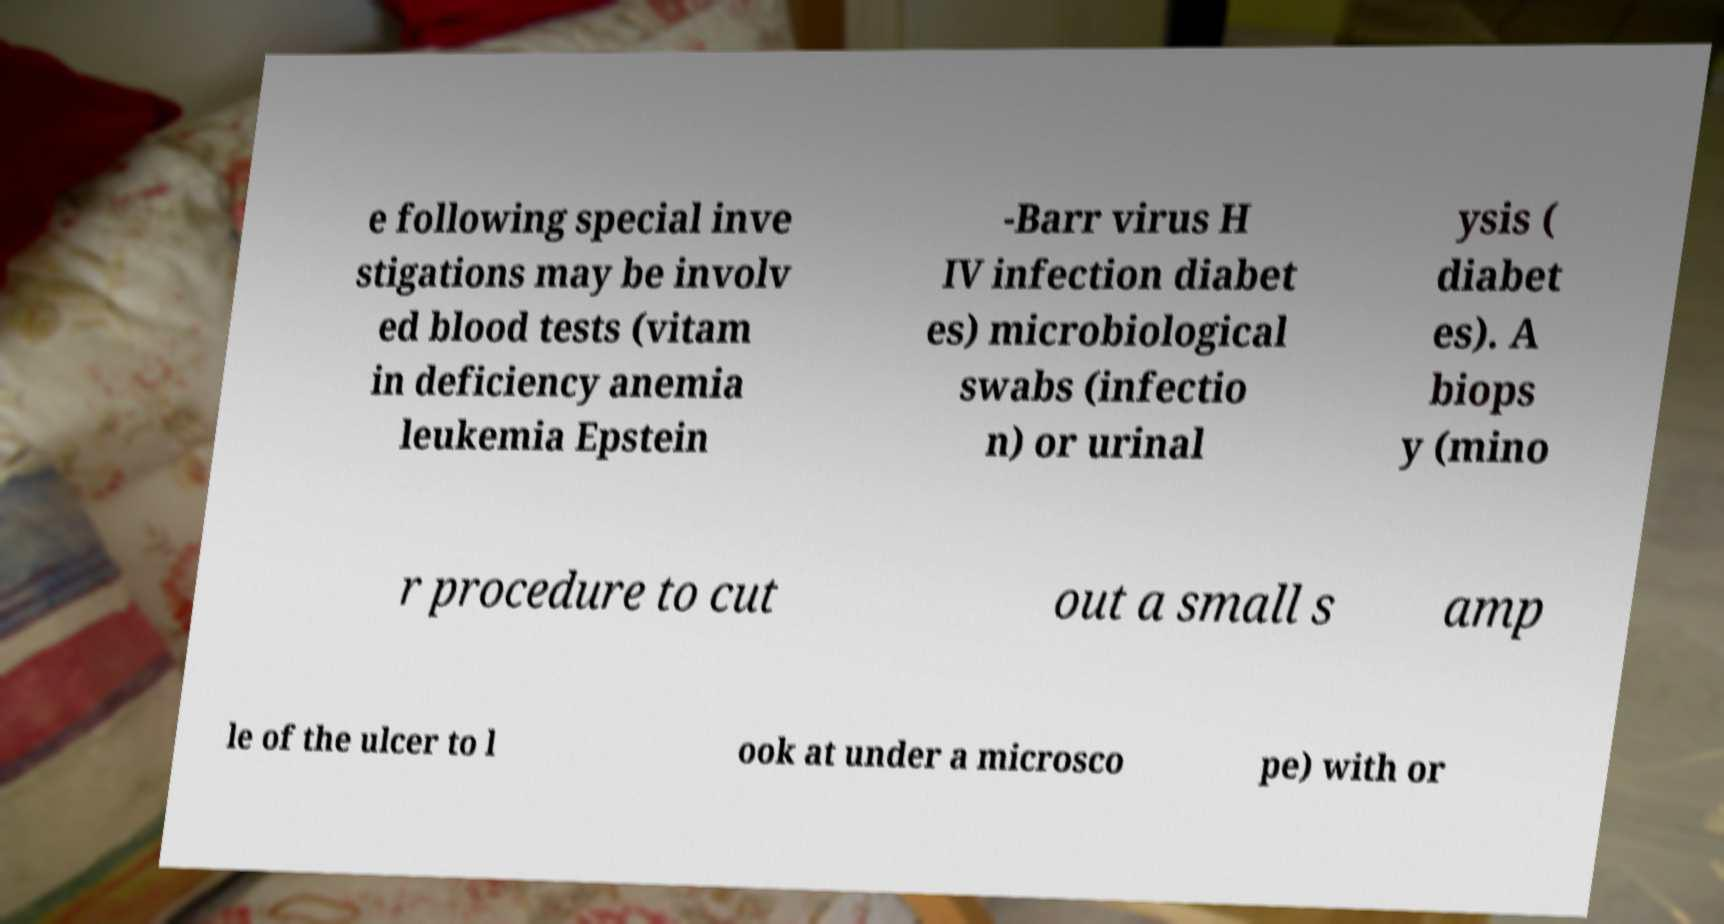Could you extract and type out the text from this image? e following special inve stigations may be involv ed blood tests (vitam in deficiency anemia leukemia Epstein -Barr virus H IV infection diabet es) microbiological swabs (infectio n) or urinal ysis ( diabet es). A biops y (mino r procedure to cut out a small s amp le of the ulcer to l ook at under a microsco pe) with or 